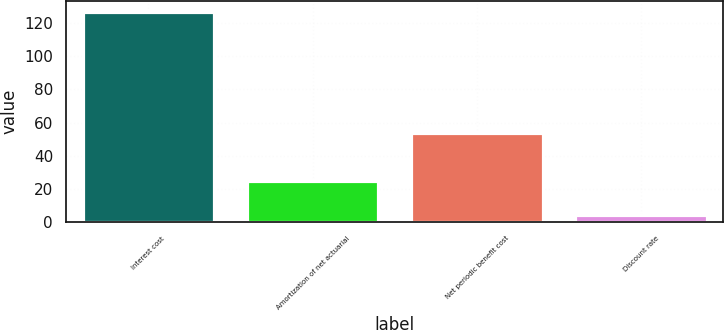<chart> <loc_0><loc_0><loc_500><loc_500><bar_chart><fcel>Interest cost<fcel>Amortization of net actuarial<fcel>Net periodic benefit cost<fcel>Discount rate<nl><fcel>127<fcel>25<fcel>54<fcel>4.34<nl></chart> 